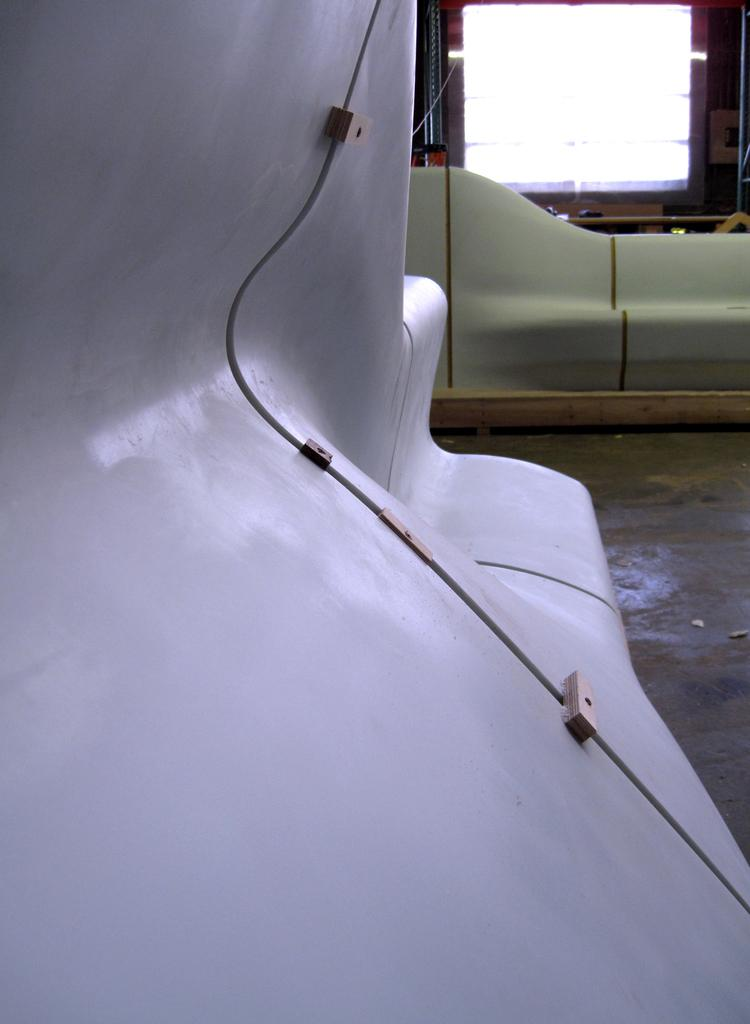What type of objects are on the floor in the image? There are metal objects on the floor. Can you describe the window in the image? There is a window at the top of the image. What color is the lip of the person in the image? There is no person present in the image, so there is no lip to describe. 